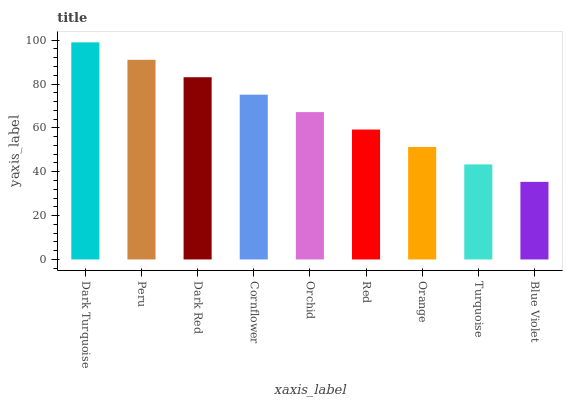Is Blue Violet the minimum?
Answer yes or no. Yes. Is Dark Turquoise the maximum?
Answer yes or no. Yes. Is Peru the minimum?
Answer yes or no. No. Is Peru the maximum?
Answer yes or no. No. Is Dark Turquoise greater than Peru?
Answer yes or no. Yes. Is Peru less than Dark Turquoise?
Answer yes or no. Yes. Is Peru greater than Dark Turquoise?
Answer yes or no. No. Is Dark Turquoise less than Peru?
Answer yes or no. No. Is Orchid the high median?
Answer yes or no. Yes. Is Orchid the low median?
Answer yes or no. Yes. Is Dark Red the high median?
Answer yes or no. No. Is Dark Red the low median?
Answer yes or no. No. 